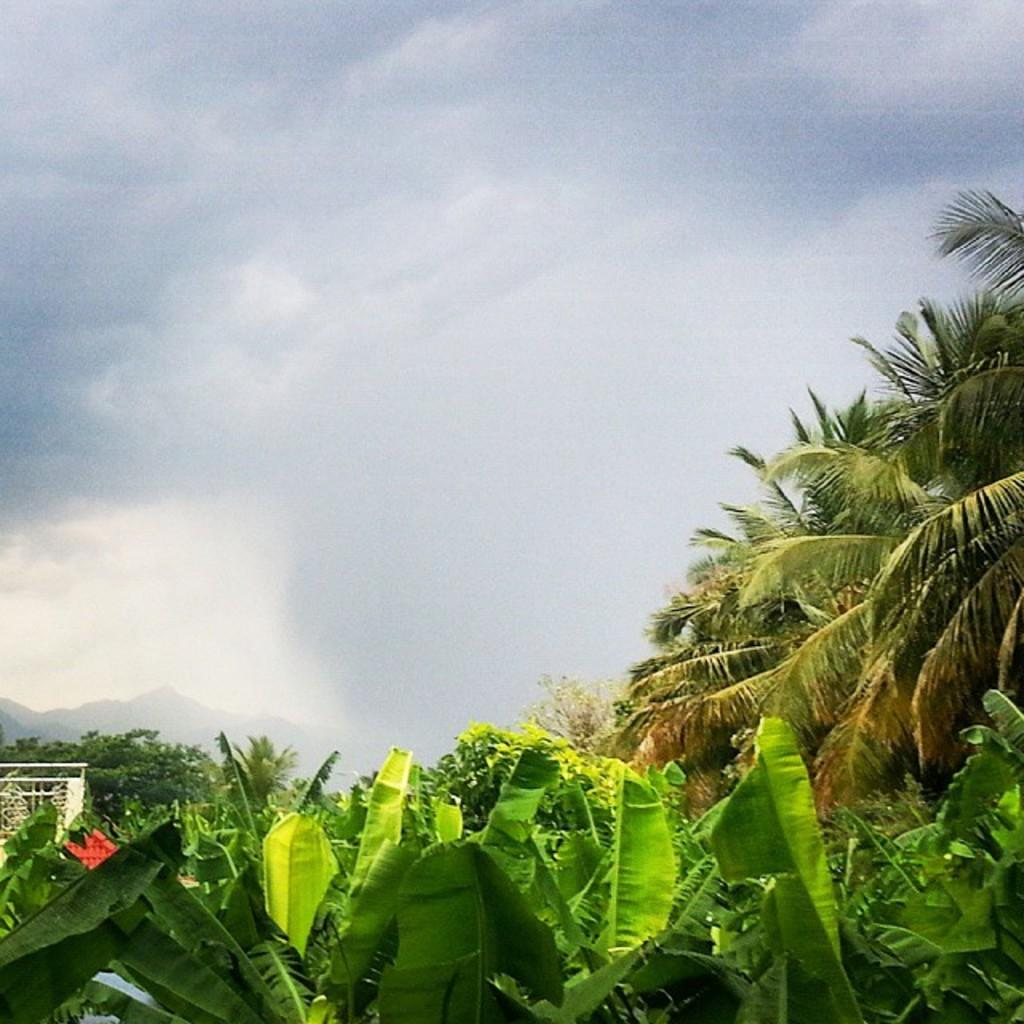What type of vegetation is present at the bottom of the image? There are trees at the bottom of the image. What is visible at the top of the image? The sky is visible at the top of the image. Where is the lettuce growing in the image? There is no lettuce present in the image. What type of animals can be seen at the zoo in the image? There is no zoo present in the image. 